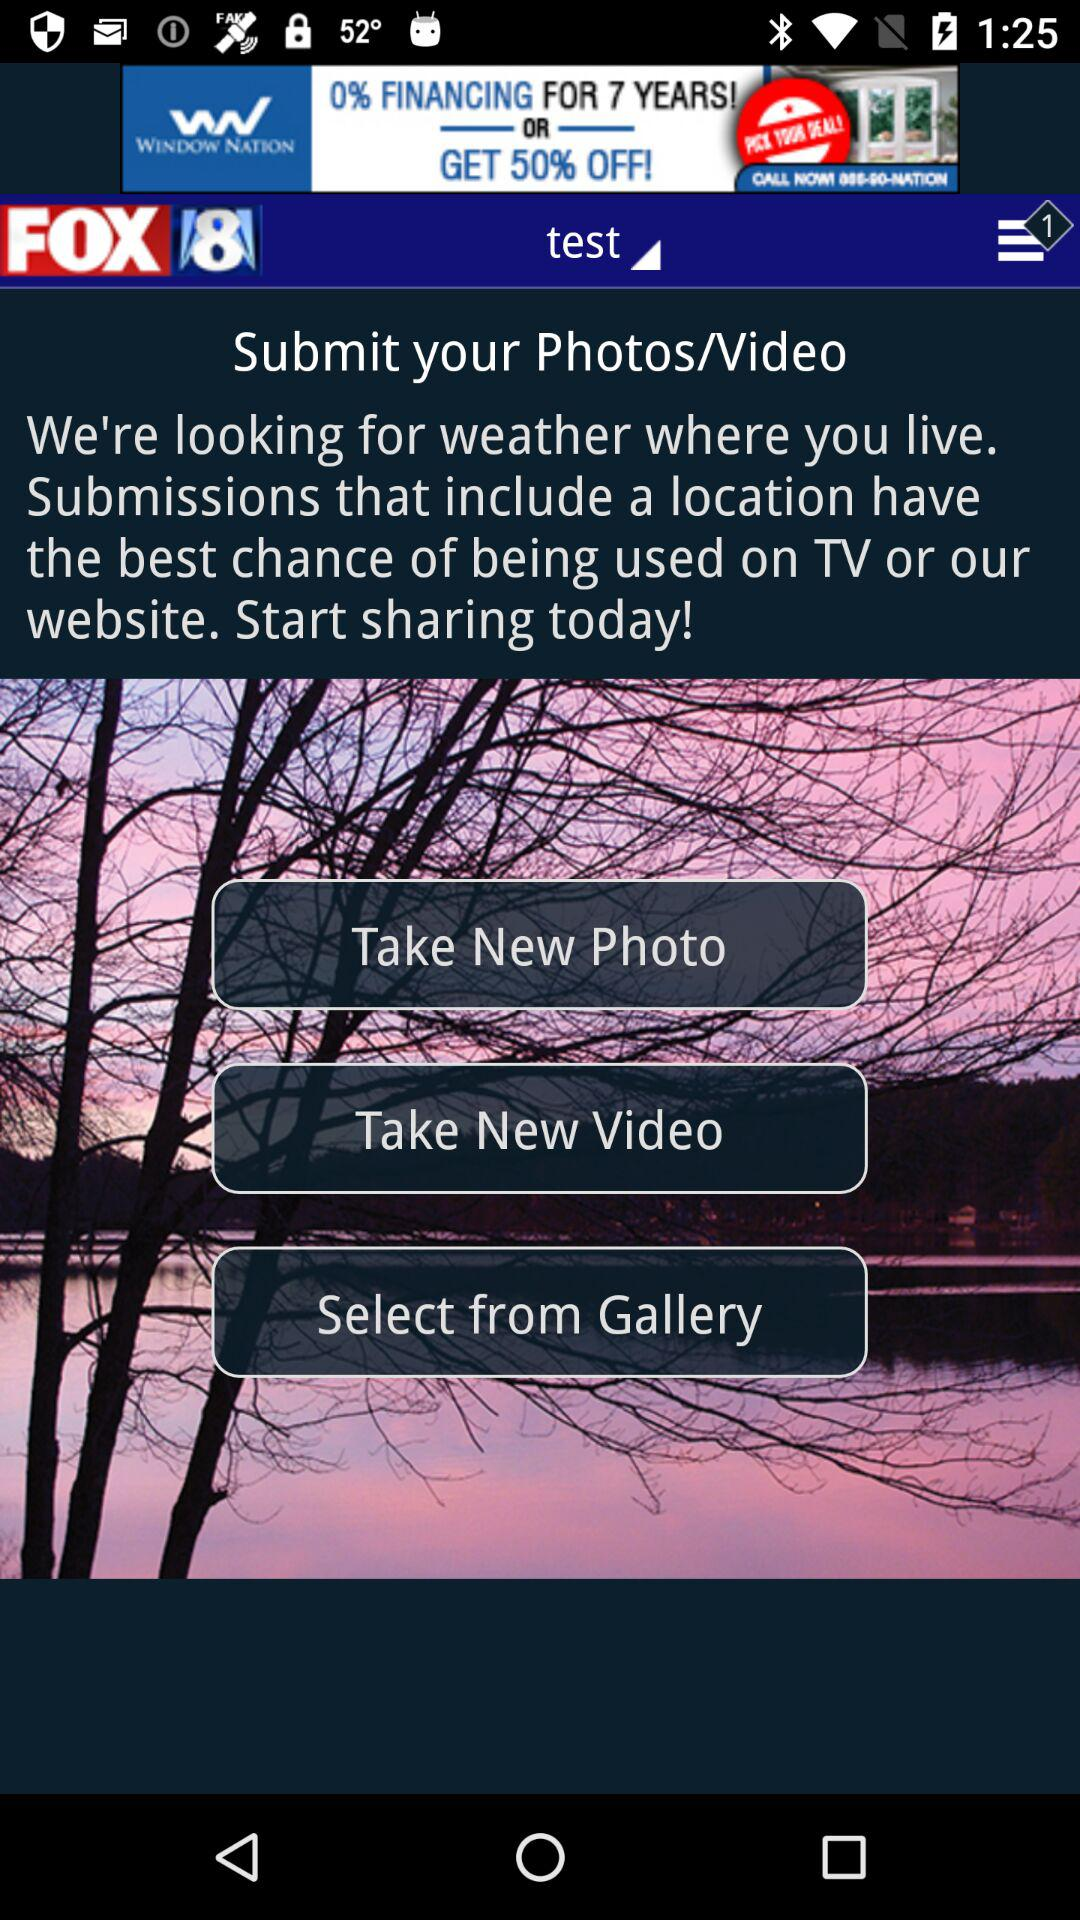Which option do we have to submit photos? The options are "Take New Photo" and "Select from Gallery". 